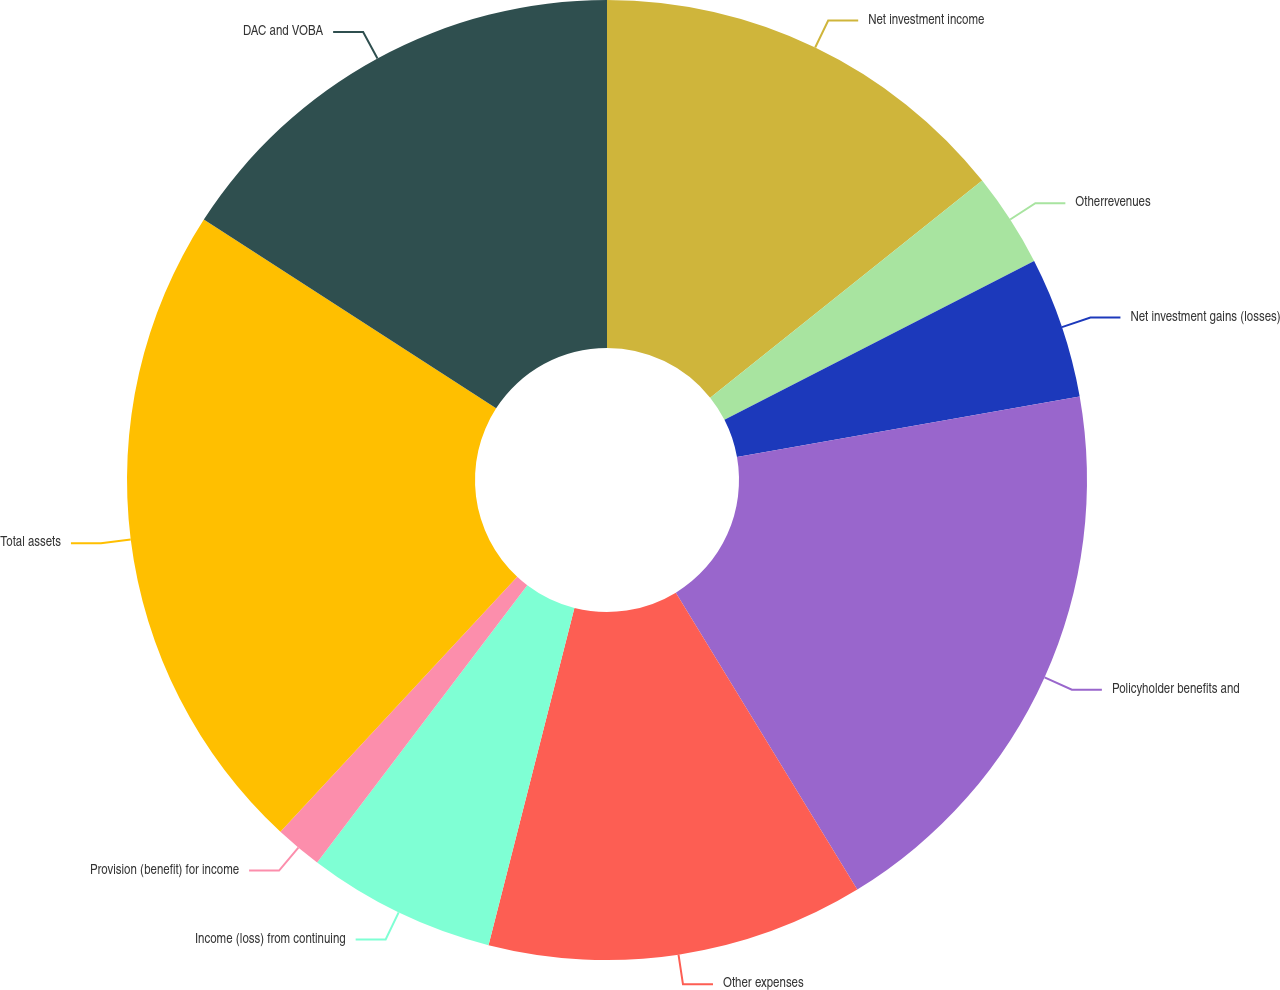Convert chart. <chart><loc_0><loc_0><loc_500><loc_500><pie_chart><fcel>Net investment income<fcel>Otherrevenues<fcel>Net investment gains (losses)<fcel>Policyholder benefits and<fcel>Other expenses<fcel>Income (loss) from continuing<fcel>Provision (benefit) for income<fcel>Total assets<fcel>DAC and VOBA<nl><fcel>14.28%<fcel>3.18%<fcel>4.76%<fcel>19.05%<fcel>12.7%<fcel>6.35%<fcel>1.59%<fcel>22.22%<fcel>15.87%<nl></chart> 